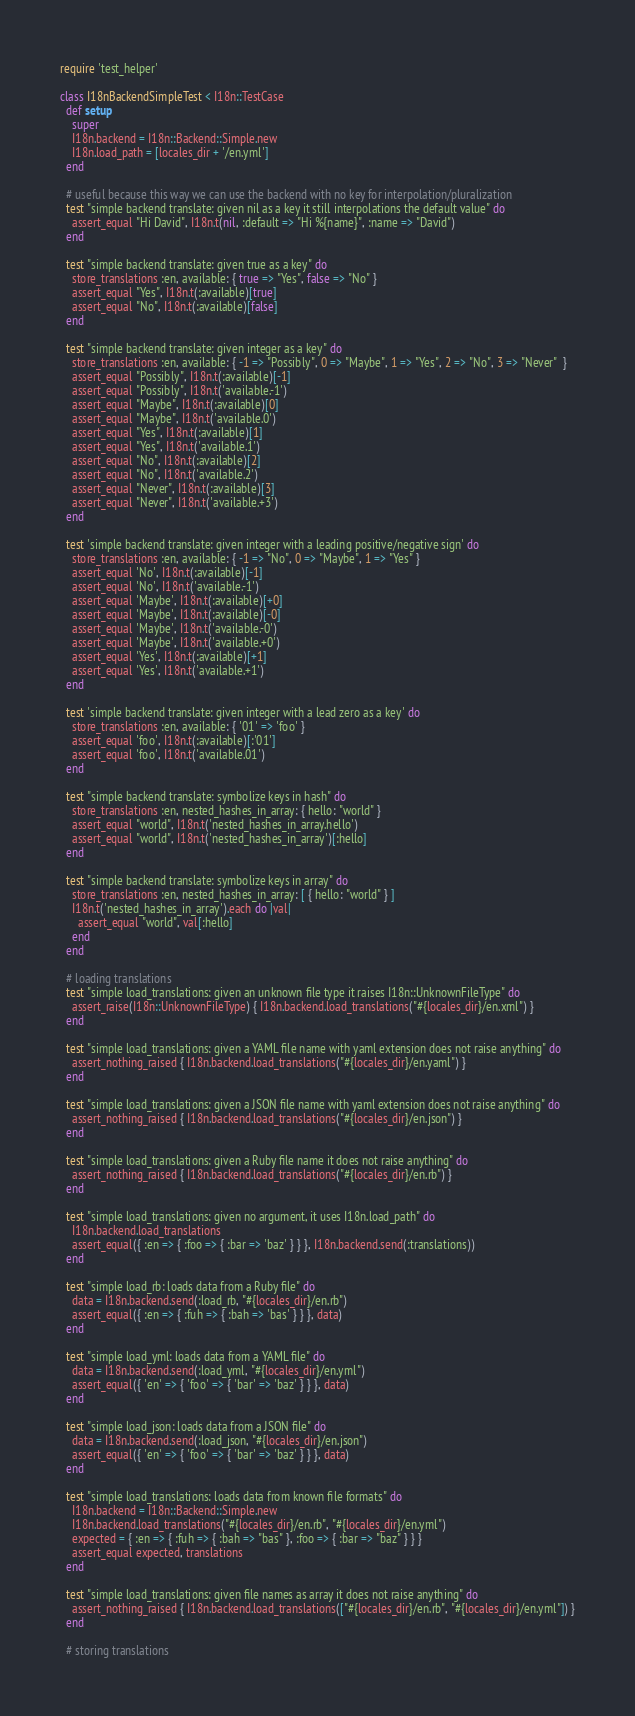Convert code to text. <code><loc_0><loc_0><loc_500><loc_500><_Ruby_>require 'test_helper'

class I18nBackendSimpleTest < I18n::TestCase
  def setup
    super
    I18n.backend = I18n::Backend::Simple.new
    I18n.load_path = [locales_dir + '/en.yml']
  end

  # useful because this way we can use the backend with no key for interpolation/pluralization
  test "simple backend translate: given nil as a key it still interpolations the default value" do
    assert_equal "Hi David", I18n.t(nil, :default => "Hi %{name}", :name => "David")
  end

  test "simple backend translate: given true as a key" do
    store_translations :en, available: { true => "Yes", false => "No" }
    assert_equal "Yes", I18n.t(:available)[true]
    assert_equal "No", I18n.t(:available)[false]
  end

  test "simple backend translate: given integer as a key" do
    store_translations :en, available: { -1 => "Possibly", 0 => "Maybe", 1 => "Yes", 2 => "No", 3 => "Never"  }
    assert_equal "Possibly", I18n.t(:available)[-1]
    assert_equal "Possibly", I18n.t('available.-1')
    assert_equal "Maybe", I18n.t(:available)[0]
    assert_equal "Maybe", I18n.t('available.0')
    assert_equal "Yes", I18n.t(:available)[1]
    assert_equal "Yes", I18n.t('available.1')
    assert_equal "No", I18n.t(:available)[2]
    assert_equal "No", I18n.t('available.2')
    assert_equal "Never", I18n.t(:available)[3]
    assert_equal "Never", I18n.t('available.+3')
  end

  test 'simple backend translate: given integer with a leading positive/negative sign' do
    store_translations :en, available: { -1 => "No", 0 => "Maybe", 1 => "Yes" }
    assert_equal 'No', I18n.t(:available)[-1]
    assert_equal 'No', I18n.t('available.-1')
    assert_equal 'Maybe', I18n.t(:available)[+0]
    assert_equal 'Maybe', I18n.t(:available)[-0]
    assert_equal 'Maybe', I18n.t('available.-0')
    assert_equal 'Maybe', I18n.t('available.+0')
    assert_equal 'Yes', I18n.t(:available)[+1]
    assert_equal 'Yes', I18n.t('available.+1')
  end

  test 'simple backend translate: given integer with a lead zero as a key' do
    store_translations :en, available: { '01' => 'foo' }
    assert_equal 'foo', I18n.t(:available)[:'01']
    assert_equal 'foo', I18n.t('available.01')
  end

  test "simple backend translate: symbolize keys in hash" do
    store_translations :en, nested_hashes_in_array: { hello: "world" }
    assert_equal "world", I18n.t('nested_hashes_in_array.hello')
    assert_equal "world", I18n.t('nested_hashes_in_array')[:hello]
  end

  test "simple backend translate: symbolize keys in array" do
    store_translations :en, nested_hashes_in_array: [ { hello: "world" } ]
    I18n.t('nested_hashes_in_array').each do |val|
      assert_equal "world", val[:hello]
    end
  end

  # loading translations
  test "simple load_translations: given an unknown file type it raises I18n::UnknownFileType" do
    assert_raise(I18n::UnknownFileType) { I18n.backend.load_translations("#{locales_dir}/en.xml") }
  end

  test "simple load_translations: given a YAML file name with yaml extension does not raise anything" do
    assert_nothing_raised { I18n.backend.load_translations("#{locales_dir}/en.yaml") }
  end

  test "simple load_translations: given a JSON file name with yaml extension does not raise anything" do
    assert_nothing_raised { I18n.backend.load_translations("#{locales_dir}/en.json") }
  end

  test "simple load_translations: given a Ruby file name it does not raise anything" do
    assert_nothing_raised { I18n.backend.load_translations("#{locales_dir}/en.rb") }
  end

  test "simple load_translations: given no argument, it uses I18n.load_path" do
    I18n.backend.load_translations
    assert_equal({ :en => { :foo => { :bar => 'baz' } } }, I18n.backend.send(:translations))
  end

  test "simple load_rb: loads data from a Ruby file" do
    data = I18n.backend.send(:load_rb, "#{locales_dir}/en.rb")
    assert_equal({ :en => { :fuh => { :bah => 'bas' } } }, data)
  end

  test "simple load_yml: loads data from a YAML file" do
    data = I18n.backend.send(:load_yml, "#{locales_dir}/en.yml")
    assert_equal({ 'en' => { 'foo' => { 'bar' => 'baz' } } }, data)
  end

  test "simple load_json: loads data from a JSON file" do
    data = I18n.backend.send(:load_json, "#{locales_dir}/en.json")
    assert_equal({ 'en' => { 'foo' => { 'bar' => 'baz' } } }, data)
  end

  test "simple load_translations: loads data from known file formats" do
    I18n.backend = I18n::Backend::Simple.new
    I18n.backend.load_translations("#{locales_dir}/en.rb", "#{locales_dir}/en.yml")
    expected = { :en => { :fuh => { :bah => "bas" }, :foo => { :bar => "baz" } } }
    assert_equal expected, translations
  end

  test "simple load_translations: given file names as array it does not raise anything" do
    assert_nothing_raised { I18n.backend.load_translations(["#{locales_dir}/en.rb", "#{locales_dir}/en.yml"]) }
  end

  # storing translations
</code> 